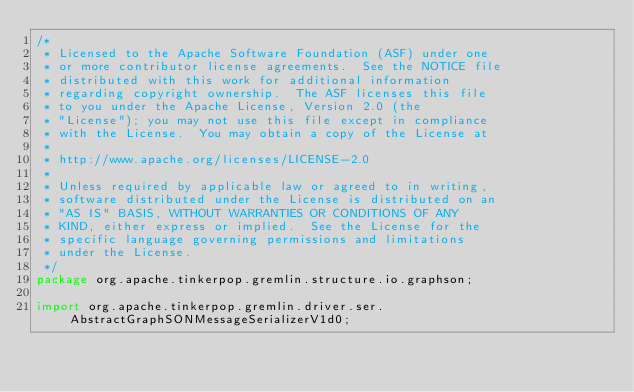<code> <loc_0><loc_0><loc_500><loc_500><_Java_>/*
 * Licensed to the Apache Software Foundation (ASF) under one
 * or more contributor license agreements.  See the NOTICE file
 * distributed with this work for additional information
 * regarding copyright ownership.  The ASF licenses this file
 * to you under the Apache License, Version 2.0 (the
 * "License"); you may not use this file except in compliance
 * with the License.  You may obtain a copy of the License at
 *
 * http://www.apache.org/licenses/LICENSE-2.0
 *
 * Unless required by applicable law or agreed to in writing,
 * software distributed under the License is distributed on an
 * "AS IS" BASIS, WITHOUT WARRANTIES OR CONDITIONS OF ANY
 * KIND, either express or implied.  See the License for the
 * specific language governing permissions and limitations
 * under the License.
 */
package org.apache.tinkerpop.gremlin.structure.io.graphson;

import org.apache.tinkerpop.gremlin.driver.ser.AbstractGraphSONMessageSerializerV1d0;</code> 